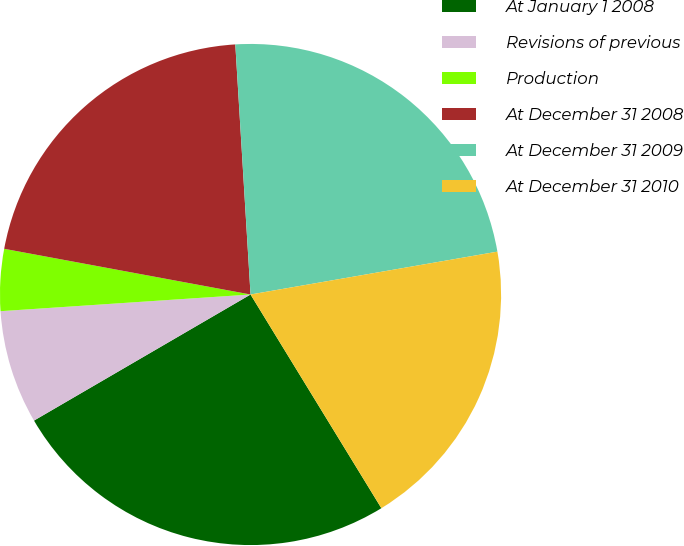Convert chart to OTSL. <chart><loc_0><loc_0><loc_500><loc_500><pie_chart><fcel>At January 1 2008<fcel>Revisions of previous<fcel>Production<fcel>At December 31 2008<fcel>At December 31 2009<fcel>At December 31 2010<nl><fcel>25.35%<fcel>7.33%<fcel>3.98%<fcel>21.11%<fcel>23.23%<fcel>18.99%<nl></chart> 